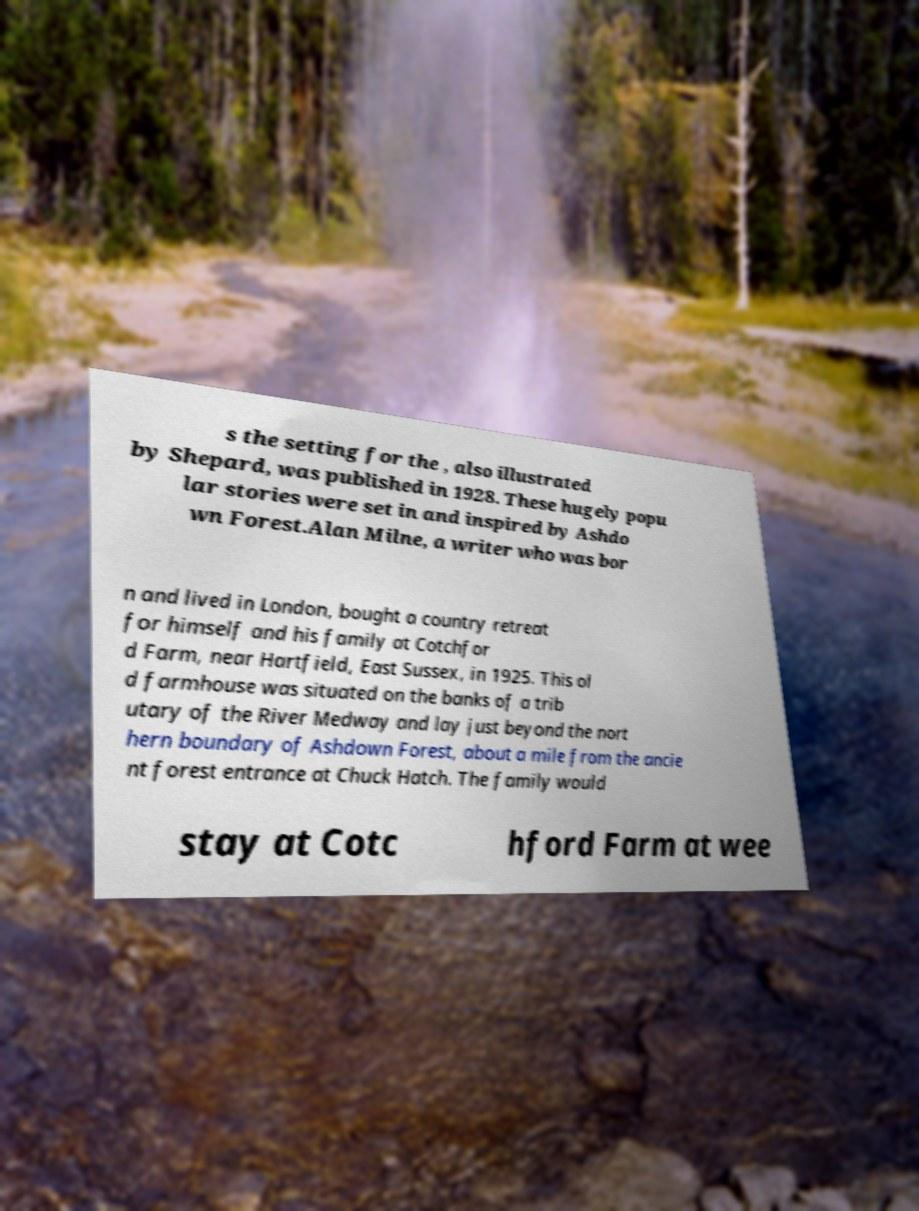What messages or text are displayed in this image? I need them in a readable, typed format. s the setting for the , also illustrated by Shepard, was published in 1928. These hugely popu lar stories were set in and inspired by Ashdo wn Forest.Alan Milne, a writer who was bor n and lived in London, bought a country retreat for himself and his family at Cotchfor d Farm, near Hartfield, East Sussex, in 1925. This ol d farmhouse was situated on the banks of a trib utary of the River Medway and lay just beyond the nort hern boundary of Ashdown Forest, about a mile from the ancie nt forest entrance at Chuck Hatch. The family would stay at Cotc hford Farm at wee 